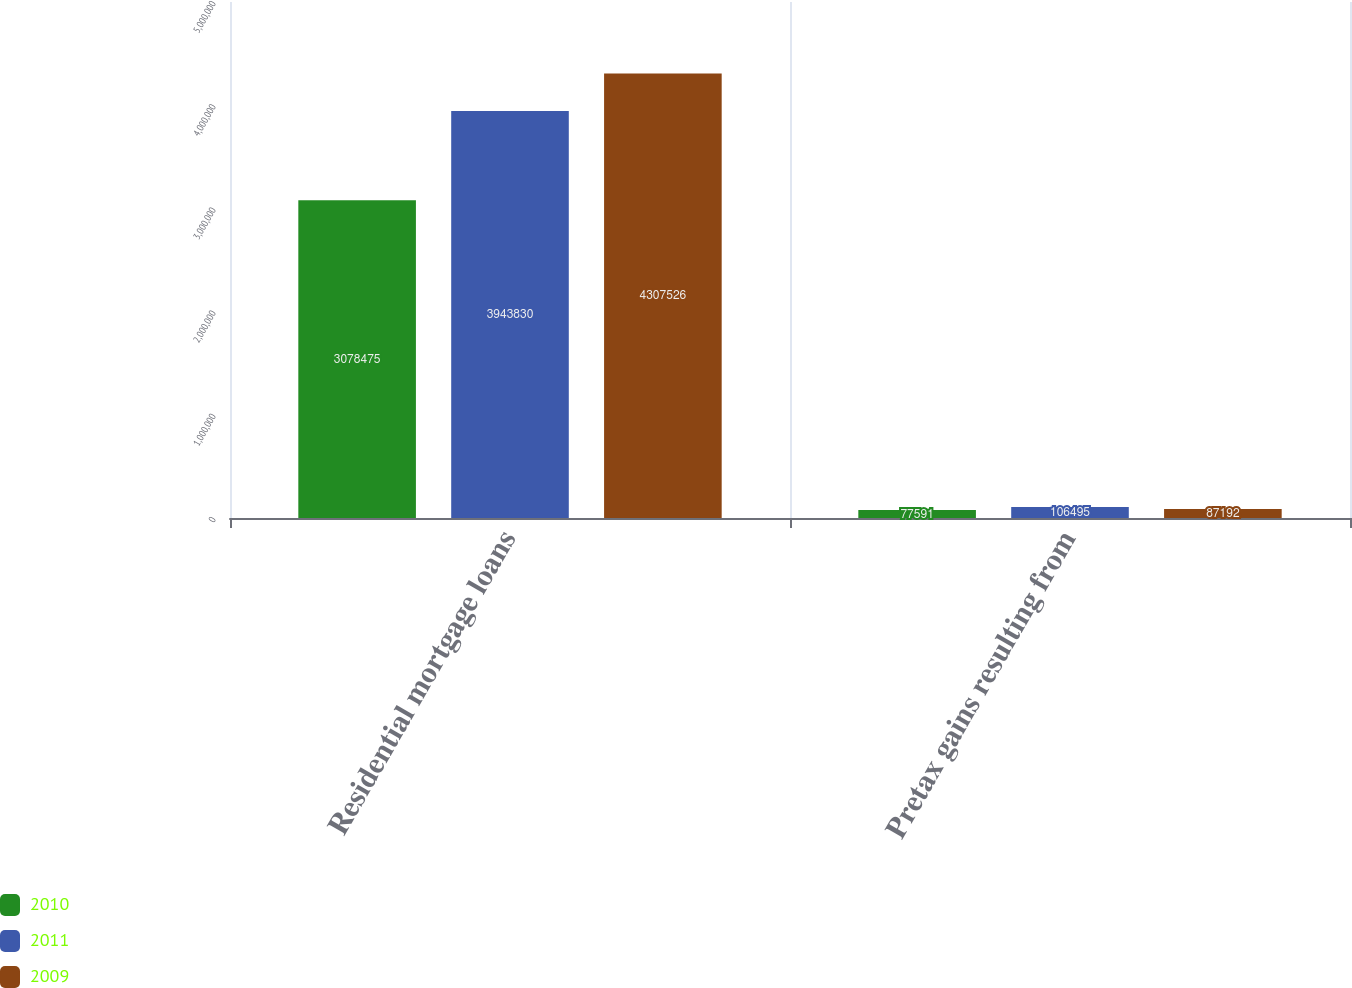Convert chart to OTSL. <chart><loc_0><loc_0><loc_500><loc_500><stacked_bar_chart><ecel><fcel>Residential mortgage loans<fcel>Pretax gains resulting from<nl><fcel>2010<fcel>3.07848e+06<fcel>77591<nl><fcel>2011<fcel>3.94383e+06<fcel>106495<nl><fcel>2009<fcel>4.30753e+06<fcel>87192<nl></chart> 